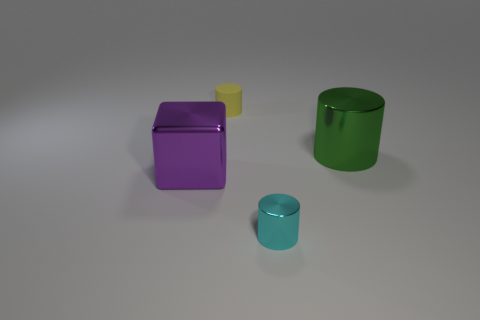Subtract all small cyan cylinders. How many cylinders are left? 2 Add 3 large cylinders. How many objects exist? 7 Subtract all yellow cylinders. How many cylinders are left? 2 Subtract all cubes. How many objects are left? 3 Add 2 tiny cyan shiny cylinders. How many tiny cyan shiny cylinders are left? 3 Add 3 large green shiny cylinders. How many large green shiny cylinders exist? 4 Subtract 0 cyan blocks. How many objects are left? 4 Subtract all cyan cubes. Subtract all red cylinders. How many cubes are left? 1 Subtract all yellow rubber cylinders. Subtract all gray rubber cubes. How many objects are left? 3 